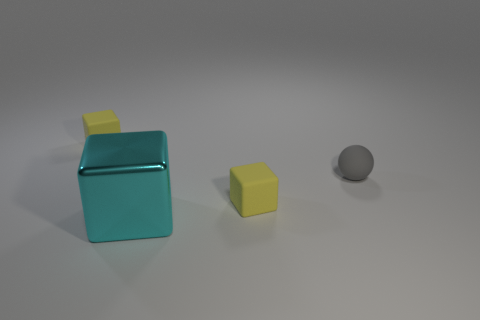Add 4 small yellow matte cubes. How many objects exist? 8 Subtract all spheres. How many objects are left? 3 Add 4 gray rubber objects. How many gray rubber objects are left? 5 Add 1 blocks. How many blocks exist? 4 Subtract 0 red balls. How many objects are left? 4 Subtract all tiny gray matte cylinders. Subtract all tiny gray matte objects. How many objects are left? 3 